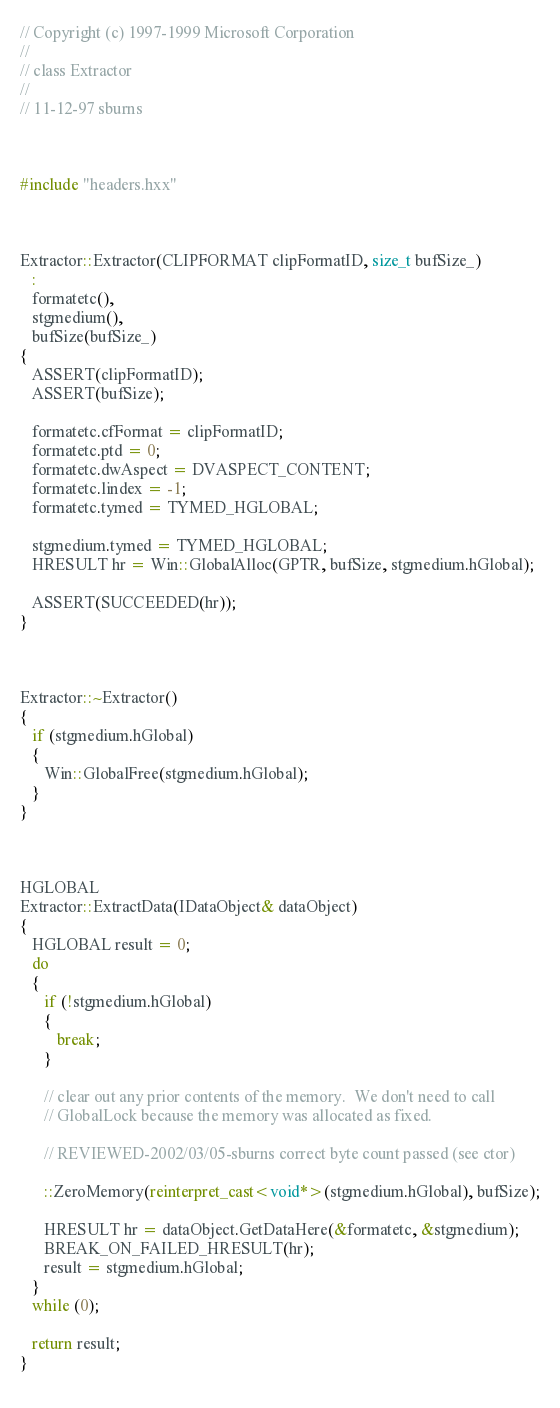Convert code to text. <code><loc_0><loc_0><loc_500><loc_500><_C++_>// Copyright (c) 1997-1999 Microsoft Corporation
// 
// class Extractor
// 
// 11-12-97 sburns



#include "headers.hxx"



Extractor::Extractor(CLIPFORMAT clipFormatID, size_t bufSize_)
   :
   formatetc(),
   stgmedium(),
   bufSize(bufSize_)
{
   ASSERT(clipFormatID);
   ASSERT(bufSize);

   formatetc.cfFormat = clipFormatID;
   formatetc.ptd = 0;
   formatetc.dwAspect = DVASPECT_CONTENT;
   formatetc.lindex = -1;
   formatetc.tymed = TYMED_HGLOBAL;

   stgmedium.tymed = TYMED_HGLOBAL;
   HRESULT hr = Win::GlobalAlloc(GPTR, bufSize, stgmedium.hGlobal);

   ASSERT(SUCCEEDED(hr));
}



Extractor::~Extractor()
{
   if (stgmedium.hGlobal)
   {
      Win::GlobalFree(stgmedium.hGlobal);
   }
}



HGLOBAL
Extractor::ExtractData(IDataObject& dataObject)
{
   HGLOBAL result = 0;
   do
   {
      if (!stgmedium.hGlobal)
      {
         break;
      }

      // clear out any prior contents of the memory.  We don't need to call
      // GlobalLock because the memory was allocated as fixed.

      // REVIEWED-2002/03/05-sburns correct byte count passed (see ctor)
      
      ::ZeroMemory(reinterpret_cast<void*>(stgmedium.hGlobal), bufSize);
      
      HRESULT hr = dataObject.GetDataHere(&formatetc, &stgmedium);
      BREAK_ON_FAILED_HRESULT(hr);
      result = stgmedium.hGlobal;
   }
   while (0);

   return result;
}
         
</code> 